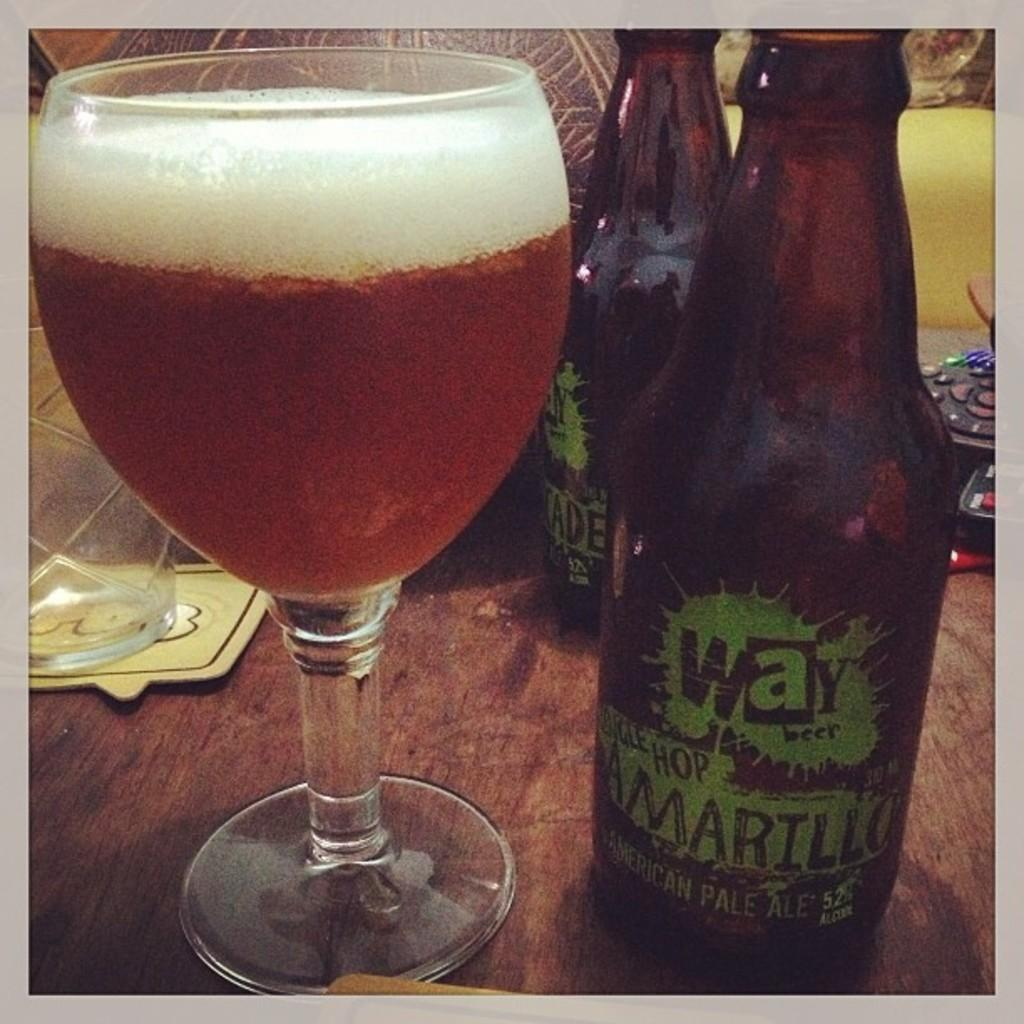What type of table is in the image? There is a wooden table in the image. What is on the wooden table? There are two wine bottles and a glass of wine on the table. What color is the egg on the wooden table in the image? There is no egg present on the wooden table in the image. 